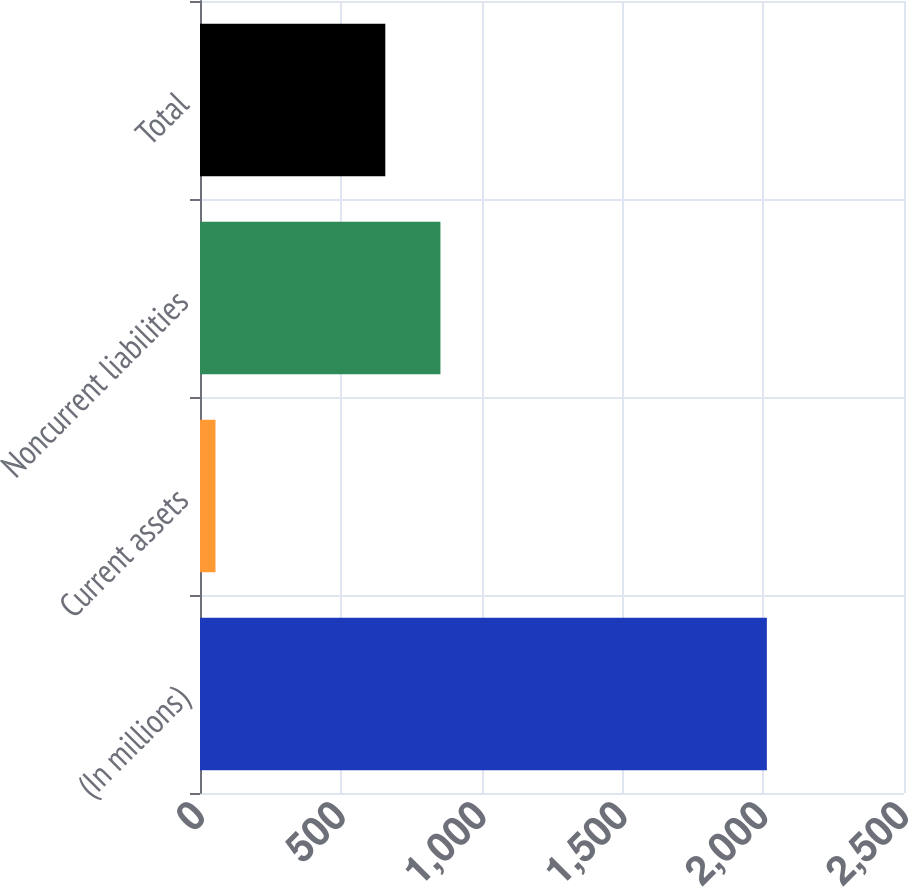<chart> <loc_0><loc_0><loc_500><loc_500><bar_chart><fcel>(In millions)<fcel>Current assets<fcel>Noncurrent liabilities<fcel>Total<nl><fcel>2013<fcel>55<fcel>853.8<fcel>658<nl></chart> 